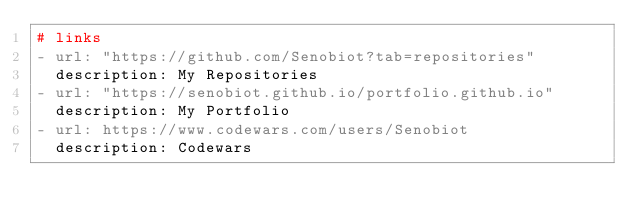Convert code to text. <code><loc_0><loc_0><loc_500><loc_500><_YAML_># links
- url: "https://github.com/Senobiot?tab=repositories"
  description: My Repositories
- url: "https://senobiot.github.io/portfolio.github.io"
  description: My Portfolio
- url: https://www.codewars.com/users/Senobiot
  description: Codewars
</code> 